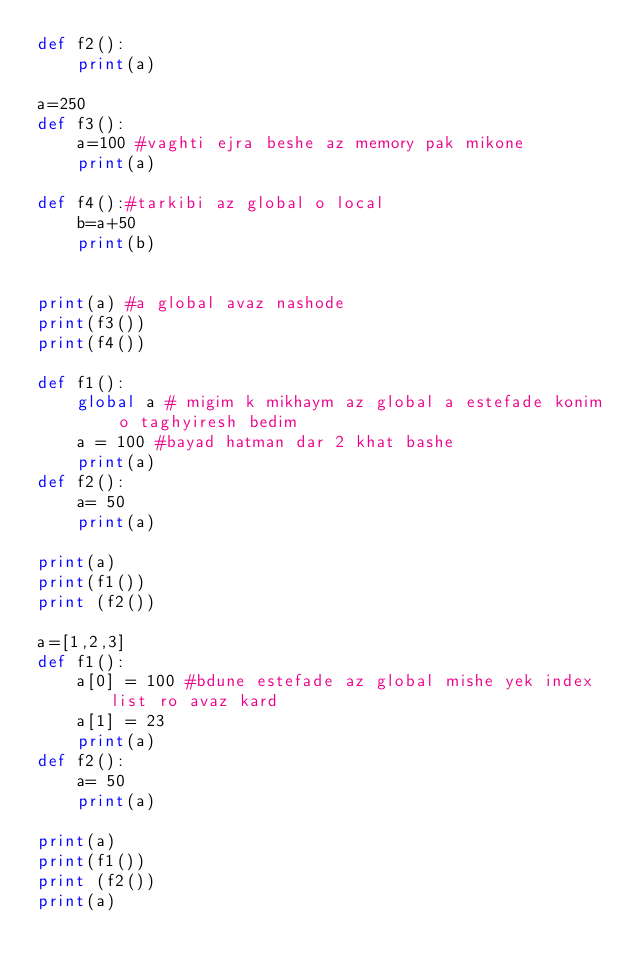<code> <loc_0><loc_0><loc_500><loc_500><_Python_>def f2():
    print(a)

a=250
def f3():
    a=100 #vaghti ejra beshe az memory pak mikone
    print(a)
    
def f4():#tarkibi az global o local
    b=a+50
    print(b)


print(a) #a global avaz nashode
print(f3())
print(f4())

def f1():
    global a # migim k mikhaym az global a estefade konim o taghyiresh bedim
    a = 100 #bayad hatman dar 2 khat bashe
    print(a)
def f2():
    a= 50
    print(a)

print(a)
print(f1())
print (f2())

a=[1,2,3]
def f1():
    a[0] = 100 #bdune estefade az global mishe yek index list ro avaz kard
    a[1] = 23
    print(a)
def f2():
    a= 50
    print(a)

print(a)
print(f1())
print (f2())
print(a)

</code> 